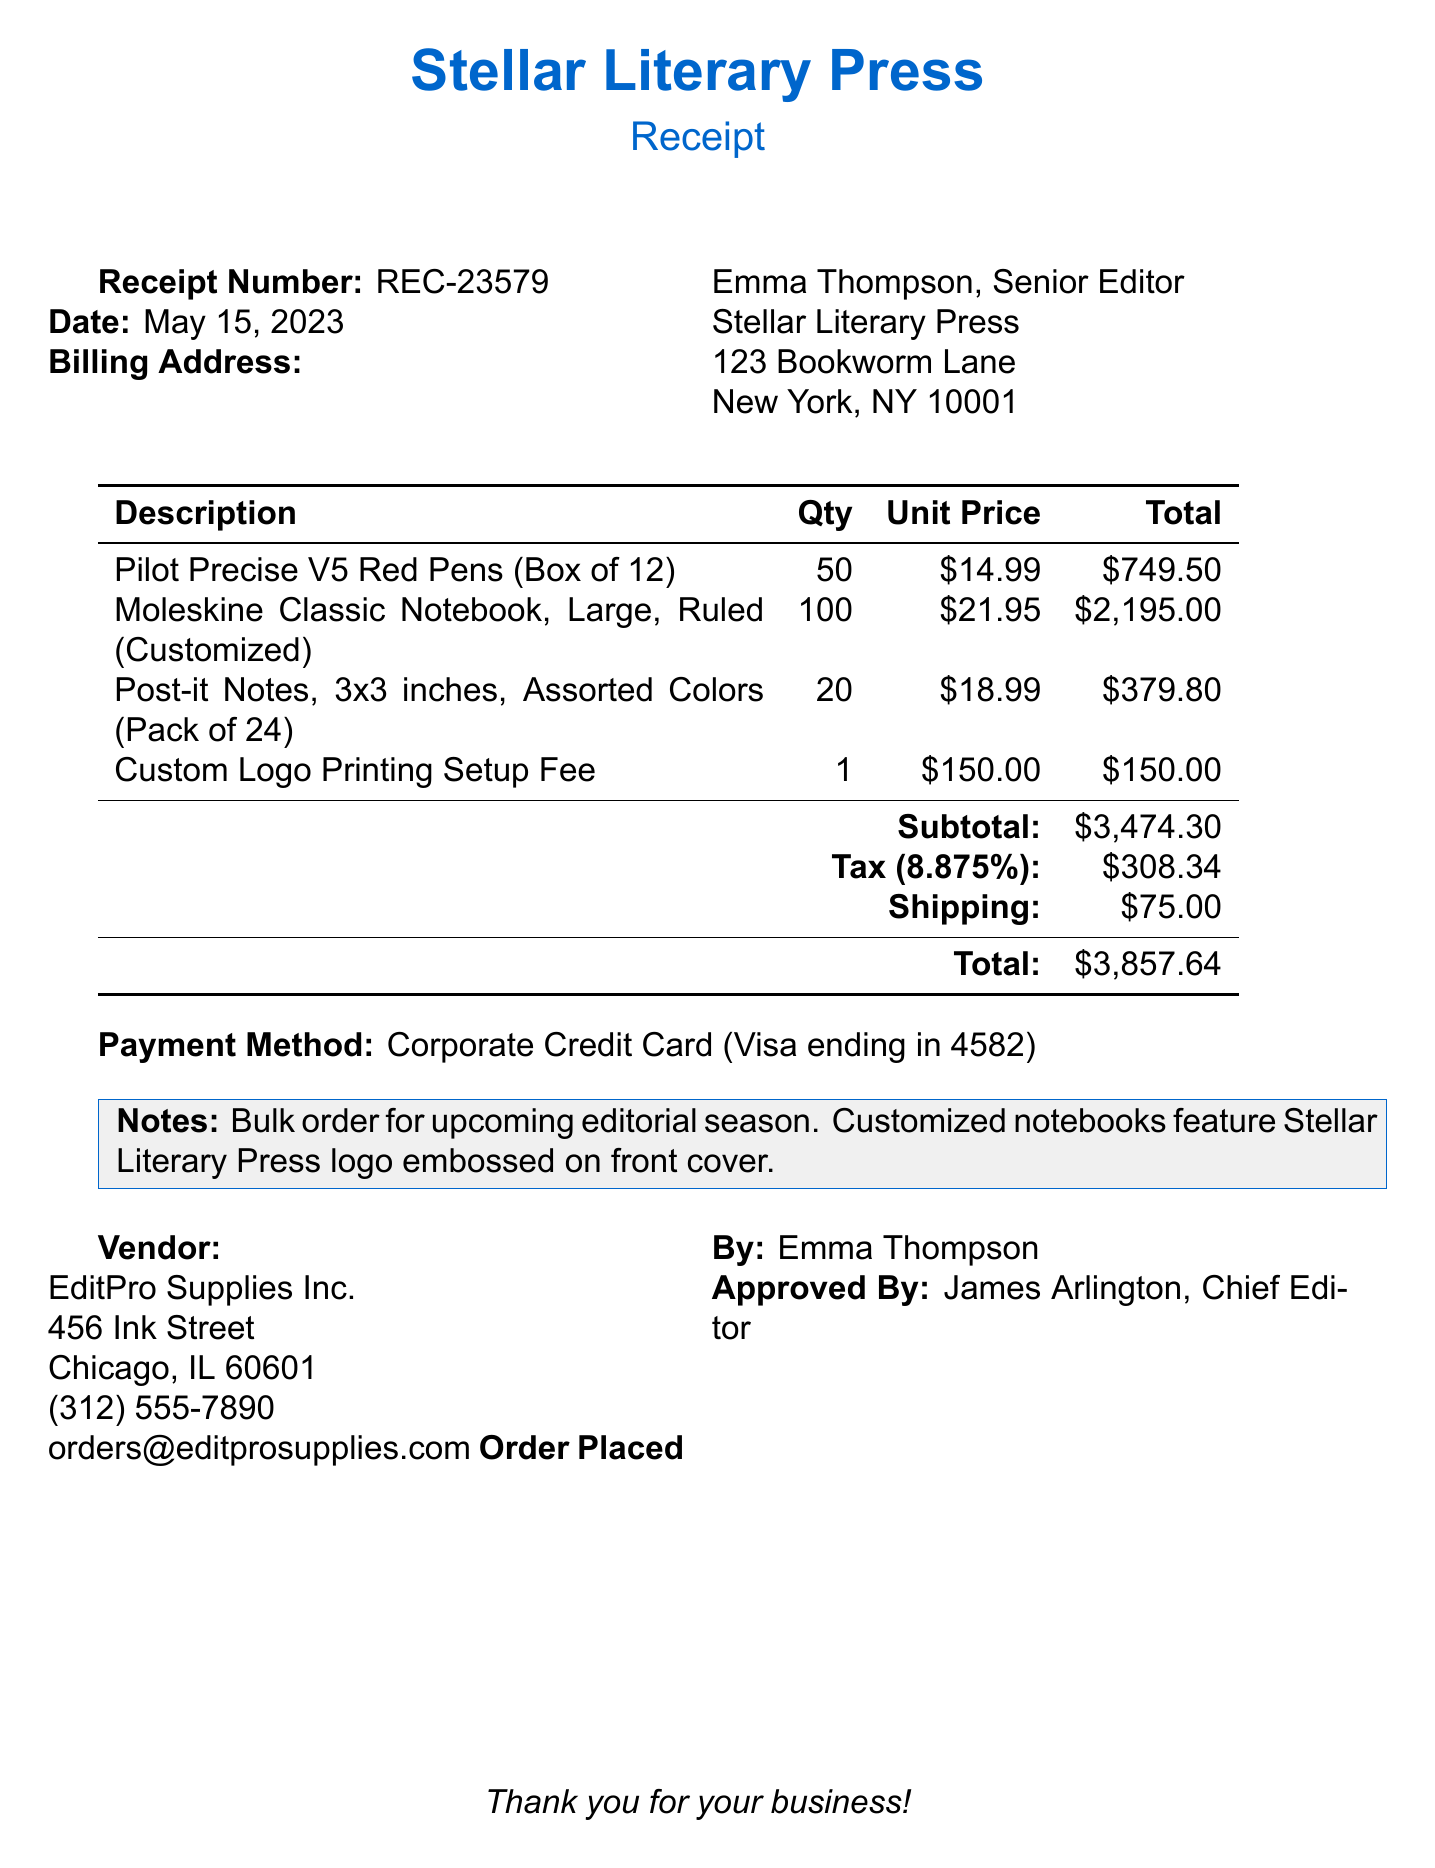What is the receipt number? The receipt number is a unique identifier for the transaction, listed in the document.
Answer: REC-23579 What is the date of the order? The date indicates when the receipt was generated for the order.
Answer: May 15, 2023 Who is the billing address for this order? The billing address includes the name, title, and address of the individual responsible for the order.
Answer: Emma Thompson, Senior Editor, Stellar Literary Press, 123 Bookworm Lane, New York, NY 10001 What is the total amount of the order? The total amount is the final cost that includes all items, tax, and shipping fees calculated in the document.
Answer: $3,857.64 How many Moleskine notebooks were ordered? The quantity for Moleskine Classic Notebooks indicates how many were purchased in this order.
Answer: 100 What is the unit price of the red pens? The unit price specifies the cost per box of red pens before any taxes or discounts.
Answer: $14.99 What fee is associated with custom logo printing? The fee represents the cost for setting up the printing of the logo on the products.
Answer: $150.00 Who approved the order? The name provided indicates the person who has authorized the purchase.
Answer: James Arlington, Chief Editor What is the name of the vendor? The vendor is the supplier from whom the items were purchased in this order.
Answer: EditPro Supplies Inc 